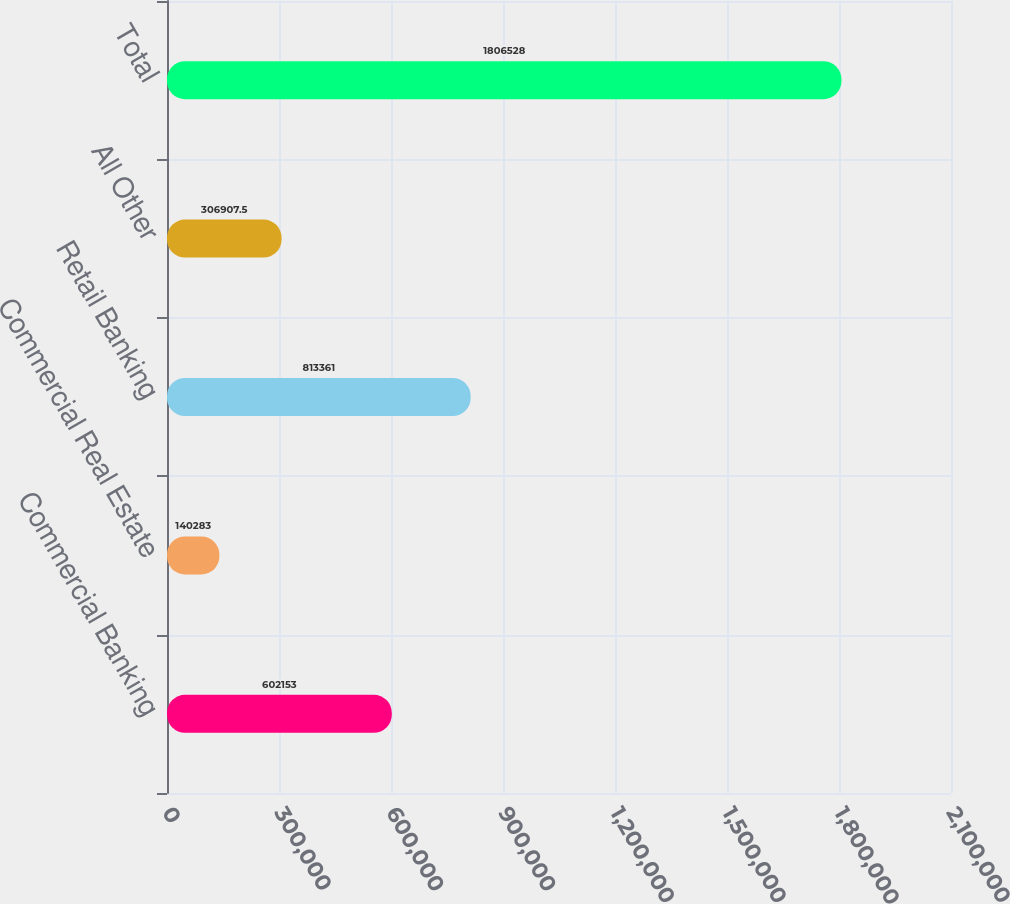Convert chart. <chart><loc_0><loc_0><loc_500><loc_500><bar_chart><fcel>Commercial Banking<fcel>Commercial Real Estate<fcel>Retail Banking<fcel>All Other<fcel>Total<nl><fcel>602153<fcel>140283<fcel>813361<fcel>306908<fcel>1.80653e+06<nl></chart> 